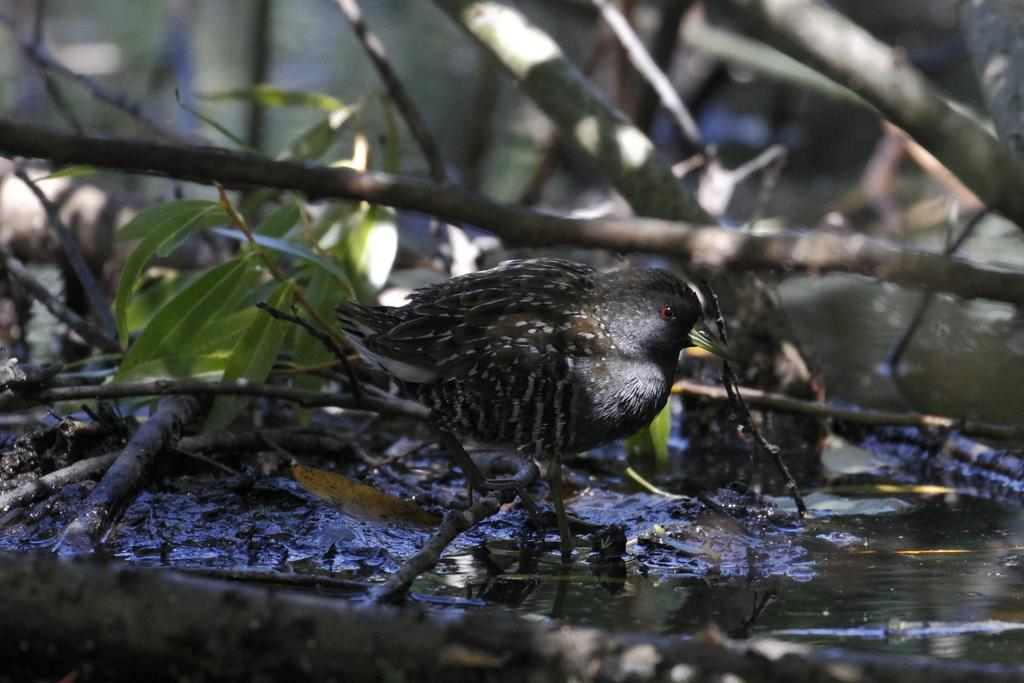What type of animal can be seen in the picture? There is a bird in the picture. What can be found among the branches in the picture? There are leaves in the picture. What are the branches attached to in the picture? The branches are attached to something, but it is not specified in the facts. What is visible in the background of the picture? Water is visible in the picture. What is the bird's profit from playing basketball in the picture? There is no bird playing basketball in the picture, and therefore no profit can be determined. 